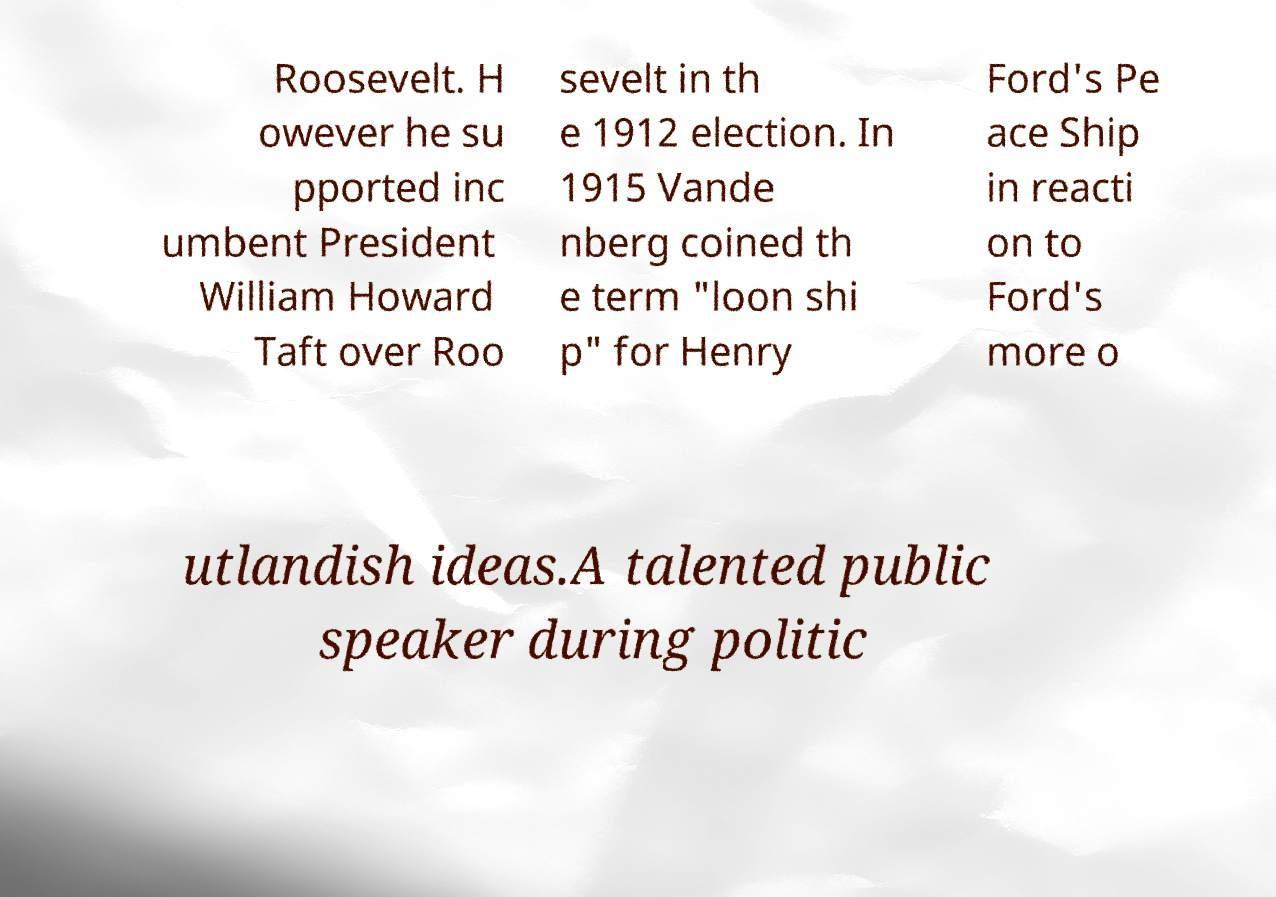Could you extract and type out the text from this image? Roosevelt. H owever he su pported inc umbent President William Howard Taft over Roo sevelt in th e 1912 election. In 1915 Vande nberg coined th e term "loon shi p" for Henry Ford's Pe ace Ship in reacti on to Ford's more o utlandish ideas.A talented public speaker during politic 